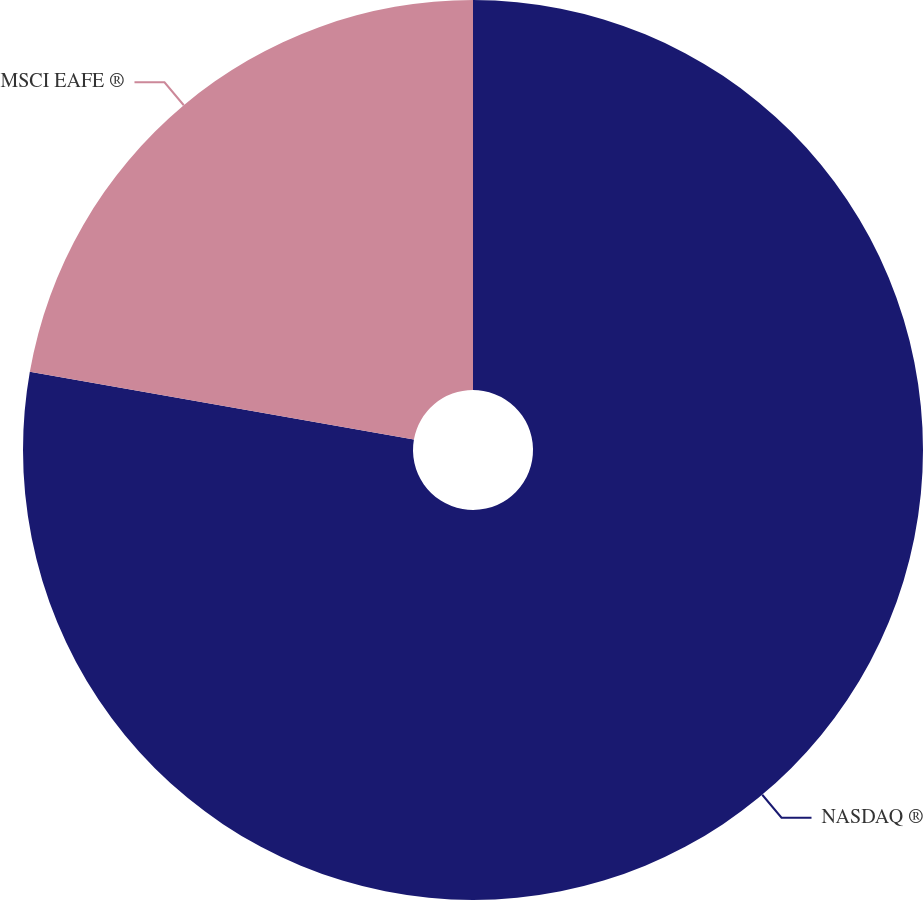Convert chart to OTSL. <chart><loc_0><loc_0><loc_500><loc_500><pie_chart><fcel>NASDAQ ®<fcel>MSCI EAFE ®<nl><fcel>77.78%<fcel>22.22%<nl></chart> 